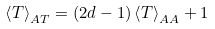Convert formula to latex. <formula><loc_0><loc_0><loc_500><loc_500>\left < T \right > _ { A T } = ( 2 d - 1 ) \left < T \right > _ { A A } + 1</formula> 